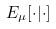Convert formula to latex. <formula><loc_0><loc_0><loc_500><loc_500>E _ { \mu } [ \cdot | \cdot ]</formula> 